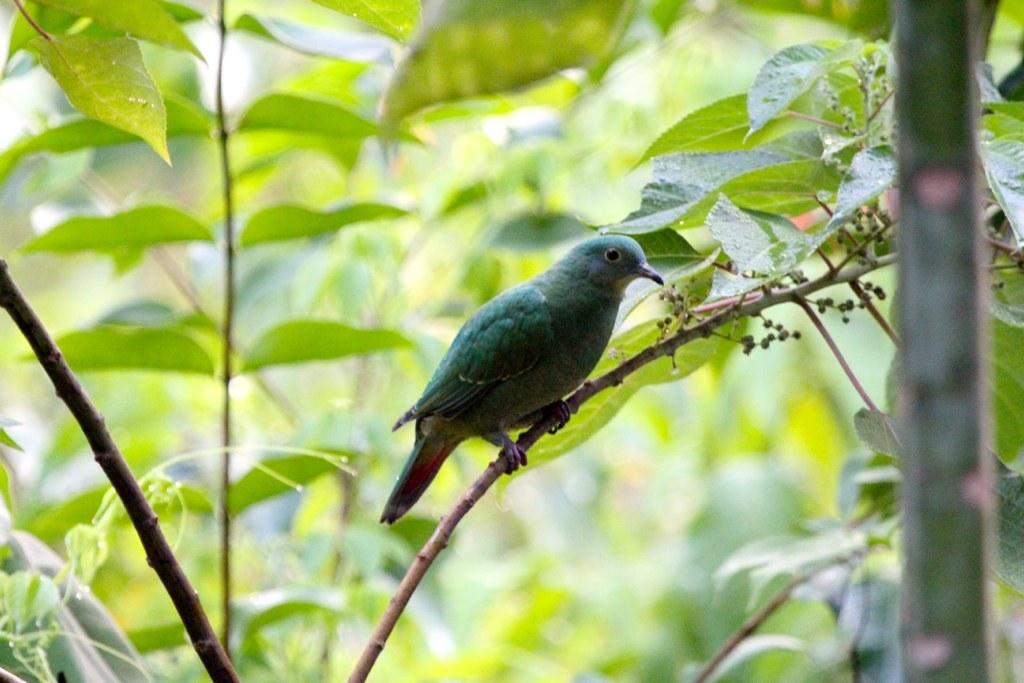What is the main subject in the center of the image? There is a bird in the center of the image. What can be seen in the background of the image? There are leaves and branches in the background of the image. What type of pancake is being served for dinner in the image? There is no pancake or dinner present in the image; it features a bird and leaves in the background. 